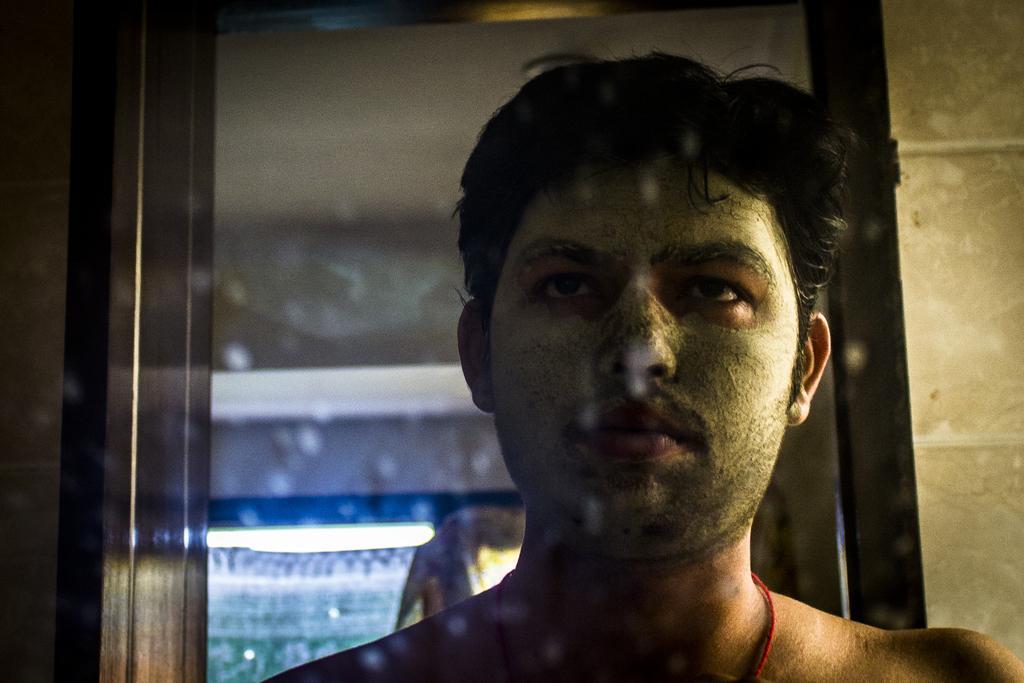Please provide a concise description of this image. In this image there is a mirror having the reflection of a person. Behind him there is a light attached to the roof. 